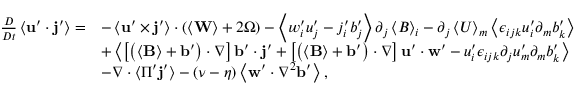Convert formula to latex. <formula><loc_0><loc_0><loc_500><loc_500>\begin{array} { r l } { \frac { D } { D t } \left \langle u ^ { \prime } \cdot j ^ { \prime } \right \rangle = } & { - \left \langle u ^ { \prime } \times j ^ { \prime } \right \rangle \cdot \left ( \left \langle W \right \rangle + 2 \Omega \right ) - \left \langle w _ { i } ^ { \prime } u _ { j } ^ { \prime } - j _ { i } ^ { \prime } b _ { j } ^ { \prime } \right \rangle \partial _ { j } \left \langle B \right \rangle _ { i } - \partial _ { j } \left \langle U \right \rangle _ { m } \left \langle \epsilon _ { i j k } u _ { i } ^ { \prime } \partial _ { m } b _ { k } ^ { \prime } \right \rangle } \\ & { + \left \langle \left [ \left ( \left \langle B \right \rangle + b ^ { \prime } \right ) \cdot \nabla \right ] b ^ { \prime } \cdot j ^ { \prime } + \left [ \left ( \left \langle B \right \rangle + b ^ { \prime } \right ) \cdot \nabla \right ] u ^ { \prime } \cdot w ^ { \prime } - u _ { i } ^ { \prime } \epsilon _ { i j k } \partial _ { j } u _ { m } ^ { \prime } \partial _ { m } b _ { k } ^ { \prime } \right \rangle } \\ & { - \nabla \cdot \left \langle \Pi ^ { \prime } j ^ { \prime } \right \rangle - \left ( \nu - \eta \right ) \left \langle w ^ { \prime } \cdot \nabla ^ { 2 } b ^ { \prime } \right \rangle , } \end{array}</formula> 